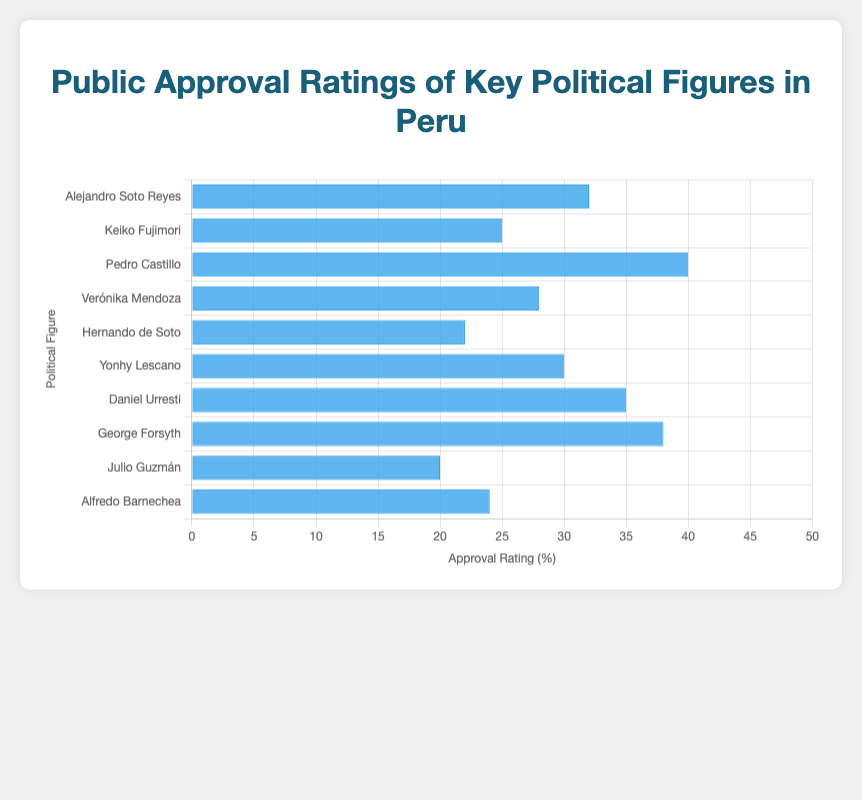Who has the highest public approval rating? The bar corresponding to Pedro Castillo is the tallest, indicating that he has the highest approval rating among the listed political figures in Peru.
Answer: Pedro Castillo What is the difference in approval ratings between Alejandro Soto Reyes and George Forsyth? Alejandro Soto Reyes has an approval rating of 32, while George Forsyth has a rating of 38. The difference is calculated as 38 - 32 = 6.
Answer: 6 Who has a higher approval rating: Keiko Fujimori or Hernando de Soto? The bar for Keiko Fujimori corresponds to an approval rating of 25, while Hernando de Soto's rating is 22. Since 25 is greater than 22, Keiko Fujimori has a higher approval rating.
Answer: Keiko Fujimori Which political figure has the lowest public approval rating? The shortest bar corresponds to Julio Guzmán, indicating he has the lowest public approval rating with 20.
Answer: Julio Guzmán What is the combined approval rating of Verónika Mendoza and Alfredo Barnechea? Verónika Mendoza has an approval rating of 28, and Alfredo Barnechea has 24. The combined rating is 28 + 24 = 52.
Answer: 52 How many political figures have an approval rating above 30%? The bars for Pedro Castillo (40), Daniel Urresti (35), and George Forsyth (38) are all above 30%. Therefore, there are 3 figures with approval ratings above 30%.
Answer: 3 What is the average approval rating of all the listed political figures? Sum the approval ratings: 32 + 25 + 40 + 28 + 22 + 30 + 35 + 38 + 20 + 24 = 294. There are 10 political figures, so the average rating is 294 / 10 = 29.4%.
Answer: 29.4% Is Alejandro Soto Reyes' approval rating closer to Keiko Fujimori's or Yonhy Lescano's? Alejandro Soto Reyes' rating is 32. The difference with Keiko Fujimori (25) is 32 - 25 = 7. The difference with Yonhy Lescano (30) is 32 - 30 = 2. Since 2 is smaller than 7, his rating is closer to Yonhy Lescano's.
Answer: Yonhy Lescano Who has a lower approval rating, Julio Guzmán or Alfredo Barnechea? Comparing the bars, Julio Guzmán has an approval rating of 20, while Alfredo Barnechea has 24. Since 20 is less than 24, Julio Guzmán has a lower rating.
Answer: Julio Guzmán Which three political figures have the highest approval ratings? The tallest three bars correspond to Pedro Castillo (40), George Forsyth (38), and Daniel Urresti (35), indicating they have the highest approval ratings.
Answer: Pedro Castillo, George Forsyth, Daniel Urresti 